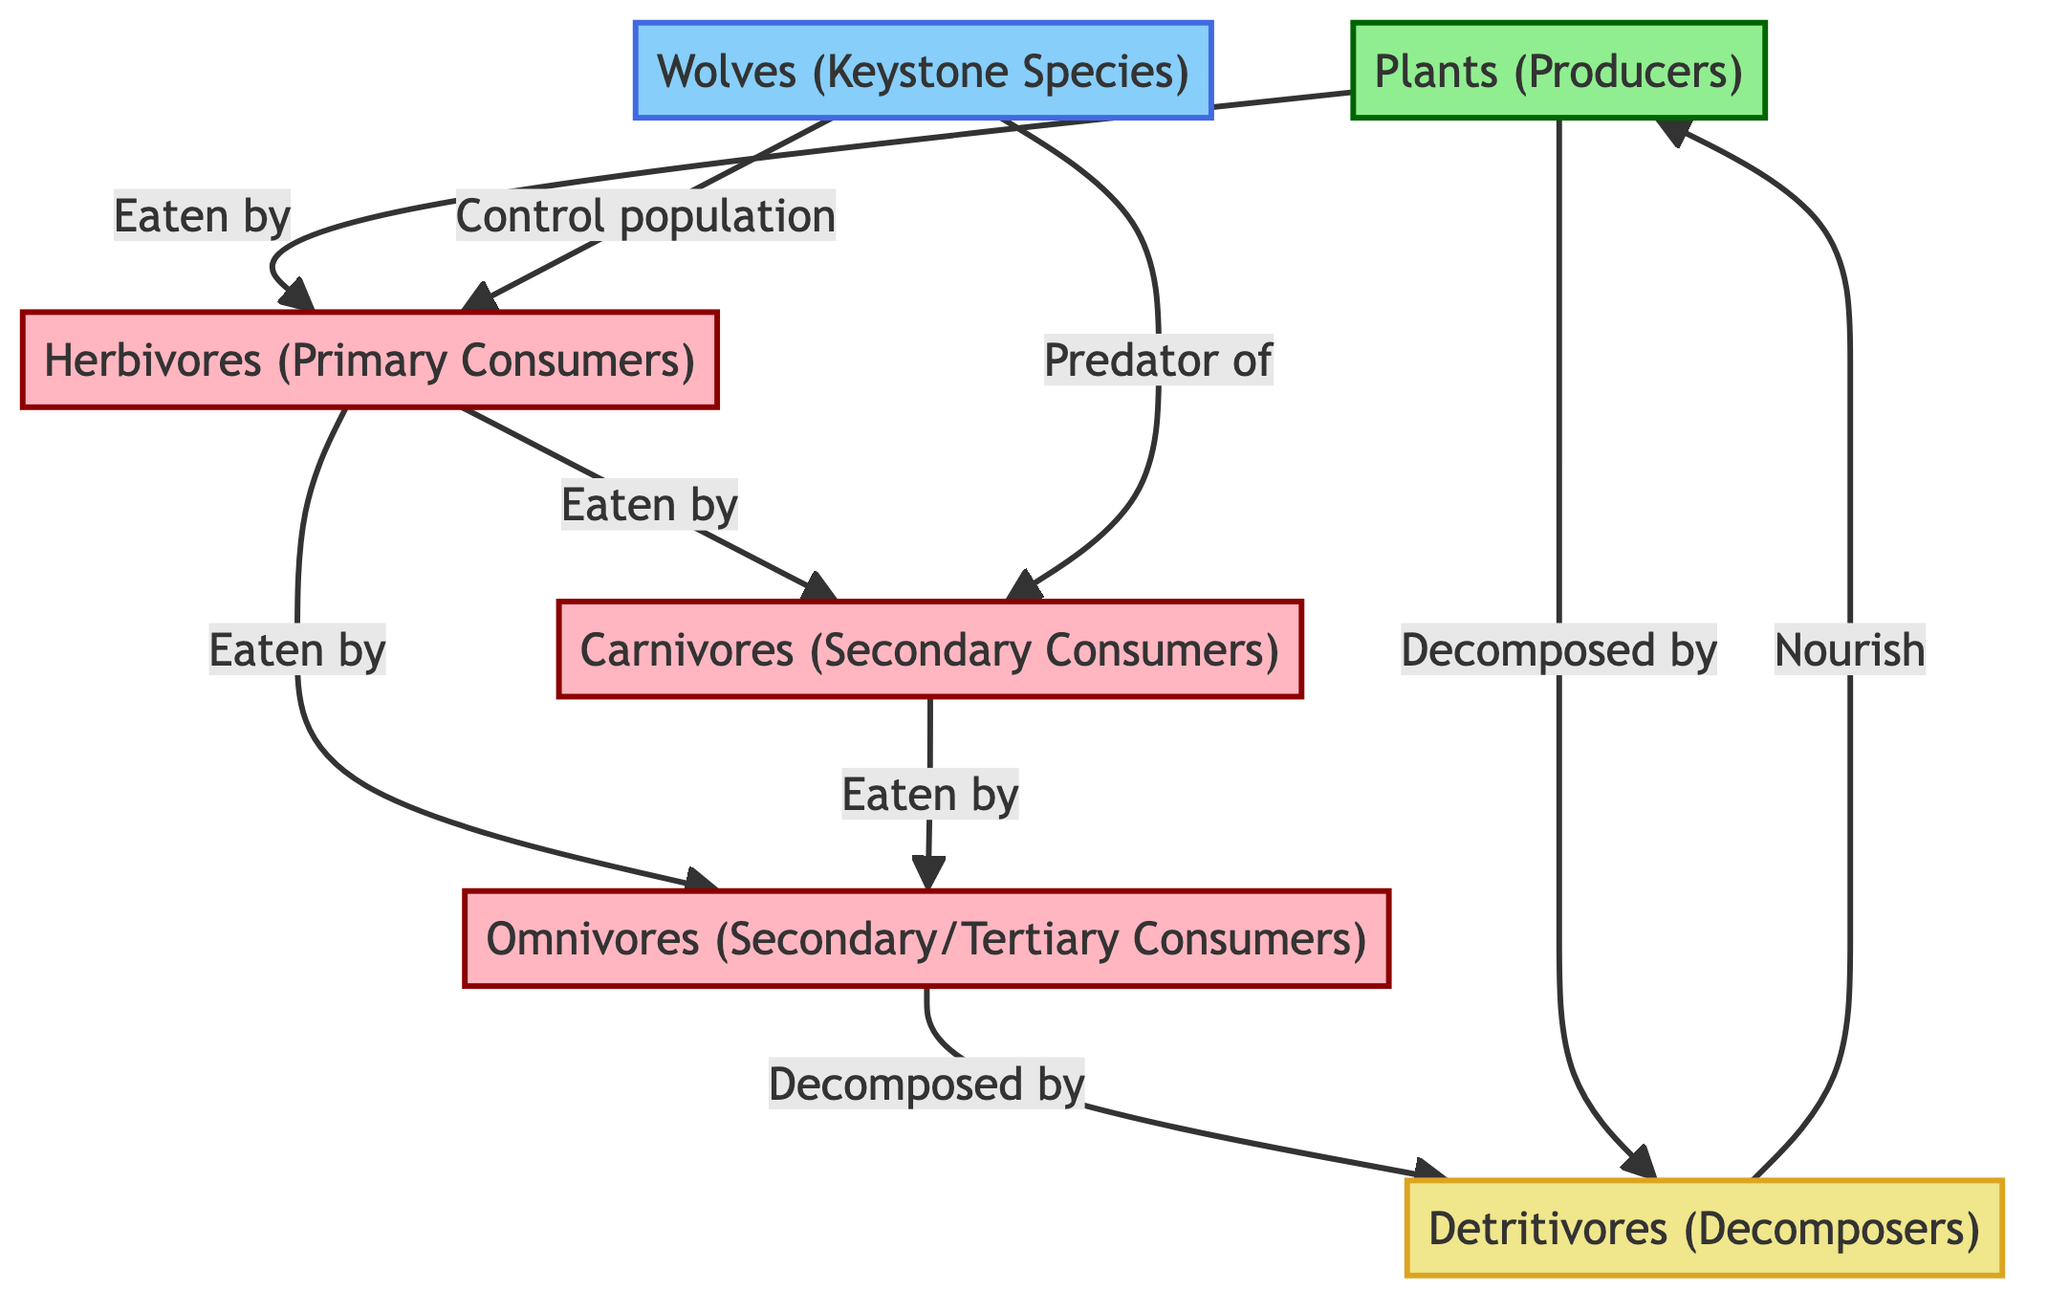What are the primary producers in this food web? The diagram indicates that the primary producers are "Plants." They are shown as the source of energy for herbivores.
Answer: Plants How many types of consumers are present in the food web? The diagram shows three distinct types of consumers: herbivores, carnivores, and omnivores. Therefore, we count them as three types.
Answer: 3 Which species is identified as the keystone species? The diagram specifically labels "Wolves" as the keystone species, highlighting their significant role in regulating the ecosystem's dynamics.
Answer: Wolves What do detritivores decompose according to the diagram? The diagram shows that detritivores are responsible for decomposing both "Omnivores" and "Plants," indicating their role in nutrient recycling.
Answer: Omnivores and Plants How do wolves affect the herbivore population? The diagram shows a direct link from the keystone species, wolves, indicating they "Control population" of herbivores, signifying their role in maintaining balance.
Answer: Control population Which group of consumers feeds on herbivores? According to the diagram, both "Carnivores" and "Omnivores" are shown to eat herbivores, making them dependent on the herbivore population for food.
Answer: Carnivores and Omnivores How do detritivores contribute back to the producers? The diagram suggests that detritivores "Nourish" plants, illustrating their role in the nutrient cycle by returning nutrients to the soil for producers.
Answer: Nourish plants What role do omnivores play in this ecosystem? The diagram indicates that omnivores can feed on both herbivores and carnivores, portraying them as versatile consumers within the food web.
Answer: Secondary/Tertiary Consumers How is the relationship between plants and herbivores depicted? The diagram shows a direct arrow from plants to herbivores labeled "Eaten by," illustrating that herbivores depend on plants for their energy and sustenance.
Answer: Eaten by What is the significance of the wolves as keystone species in the food web? The diagram emphasizes that wolves play a critical role by controlling the populations of herbivores and predating on carnivores, ensuring ecosystem balance.
Answer: Keystone Species 